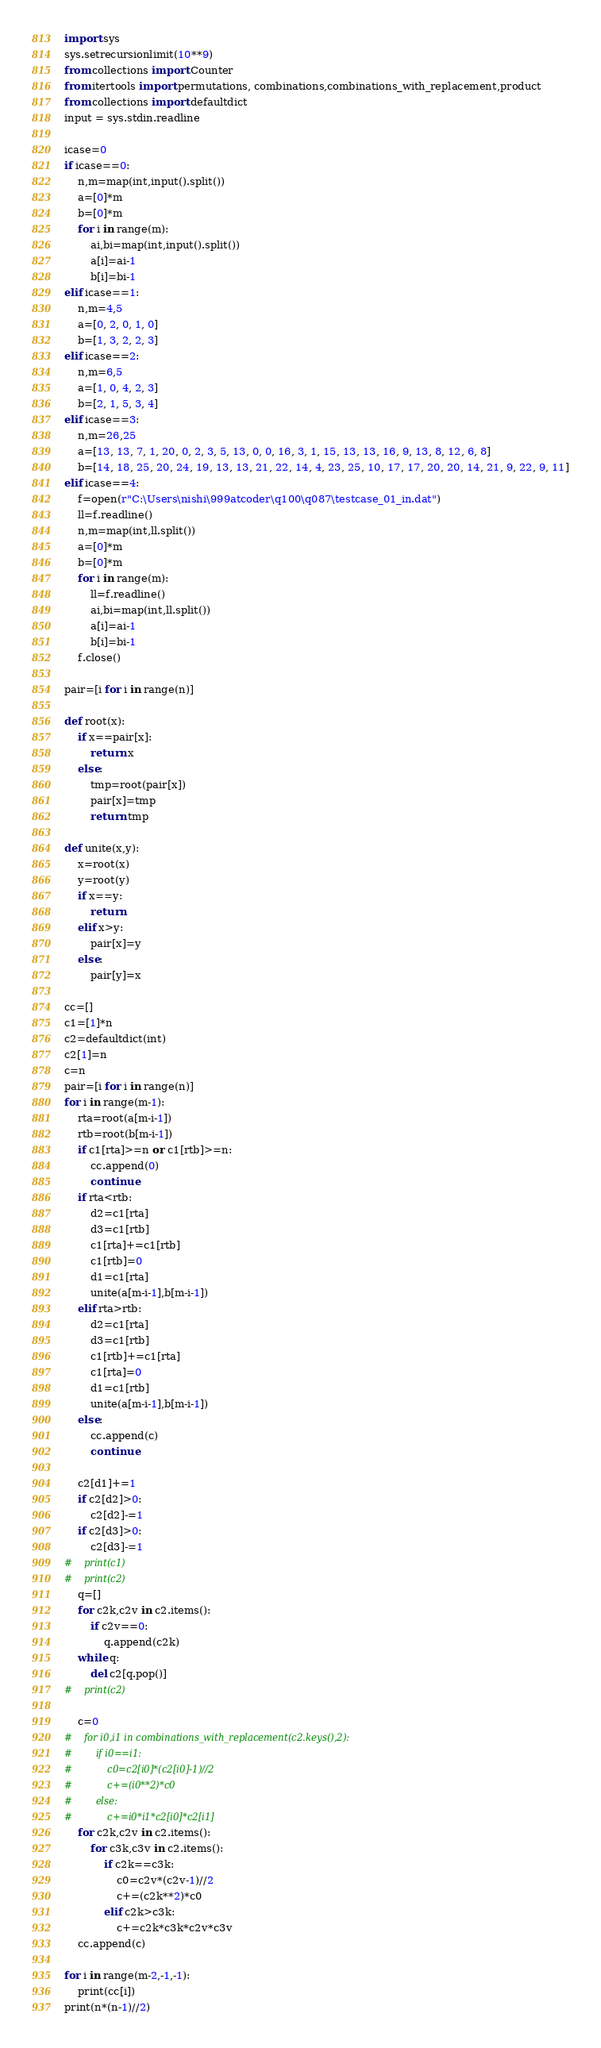<code> <loc_0><loc_0><loc_500><loc_500><_Python_>import sys
sys.setrecursionlimit(10**9)
from collections import Counter
from itertools import permutations, combinations,combinations_with_replacement,product
from collections import defaultdict
input = sys.stdin.readline
    
icase=0
if icase==0:
    n,m=map(int,input().split())
    a=[0]*m
    b=[0]*m
    for i in range(m):
        ai,bi=map(int,input().split())
        a[i]=ai-1
        b[i]=bi-1
elif icase==1:
    n,m=4,5
    a=[0, 2, 0, 1, 0]
    b=[1, 3, 2, 2, 3]
elif icase==2:
    n,m=6,5
    a=[1, 0, 4, 2, 3]
    b=[2, 1, 5, 3, 4]
elif icase==3:
    n,m=26,25
    a=[13, 13, 7, 1, 20, 0, 2, 3, 5, 13, 0, 0, 16, 3, 1, 15, 13, 13, 16, 9, 13, 8, 12, 6, 8]
    b=[14, 18, 25, 20, 24, 19, 13, 13, 21, 22, 14, 4, 23, 25, 10, 17, 17, 20, 20, 14, 21, 9, 22, 9, 11]
elif icase==4:
    f=open(r"C:\Users\nishi\999atcoder\q100\q087\testcase_01_in.dat")
    ll=f.readline()
    n,m=map(int,ll.split())
    a=[0]*m
    b=[0]*m
    for i in range(m):
        ll=f.readline()
        ai,bi=map(int,ll.split())
        a[i]=ai-1
        b[i]=bi-1
    f.close()

pair=[i for i in range(n)]

def root(x):
    if x==pair[x]:
        return x
    else:
        tmp=root(pair[x])
        pair[x]=tmp
        return tmp

def unite(x,y):
    x=root(x)
    y=root(y)
    if x==y:
        return
    elif x>y:
        pair[x]=y
    else:
        pair[y]=x

cc=[]
c1=[1]*n
c2=defaultdict(int)
c2[1]=n
c=n    
pair=[i for i in range(n)]
for i in range(m-1):
    rta=root(a[m-i-1])
    rtb=root(b[m-i-1])
    if c1[rta]>=n or c1[rtb]>=n:
        cc.append(0)
        continue
    if rta<rtb:
        d2=c1[rta]
        d3=c1[rtb]
        c1[rta]+=c1[rtb]
        c1[rtb]=0
        d1=c1[rta]
        unite(a[m-i-1],b[m-i-1])
    elif rta>rtb:
        d2=c1[rta]
        d3=c1[rtb]
        c1[rtb]+=c1[rta]
        c1[rta]=0
        d1=c1[rtb]
        unite(a[m-i-1],b[m-i-1])
    else:
        cc.append(c)
        continue

    c2[d1]+=1    
    if c2[d2]>0:
        c2[d2]-=1
    if c2[d3]>0:
        c2[d3]-=1
#    print(c1)        
#    print(c2)     
    q=[]
    for c2k,c2v in c2.items():
        if c2v==0:
            q.append(c2k)
    while q:
        del c2[q.pop()]            
#    print(c2)     
 
    c=0
#    for i0,i1 in combinations_with_replacement(c2.keys(),2):
#        if i0==i1:
#            c0=c2[i0]*(c2[i0]-1)//2
#            c+=(i0**2)*c0
#        else:
#            c+=i0*i1*c2[i0]*c2[i1]
    for c2k,c2v in c2.items():
        for c3k,c3v in c2.items():
            if c2k==c3k:
                c0=c2v*(c2v-1)//2
                c+=(c2k**2)*c0
            elif c2k>c3k:
                c+=c2k*c3k*c2v*c3v
    cc.append(c)

for i in range(m-2,-1,-1):
    print(cc[i])
print(n*(n-1)//2)
</code> 